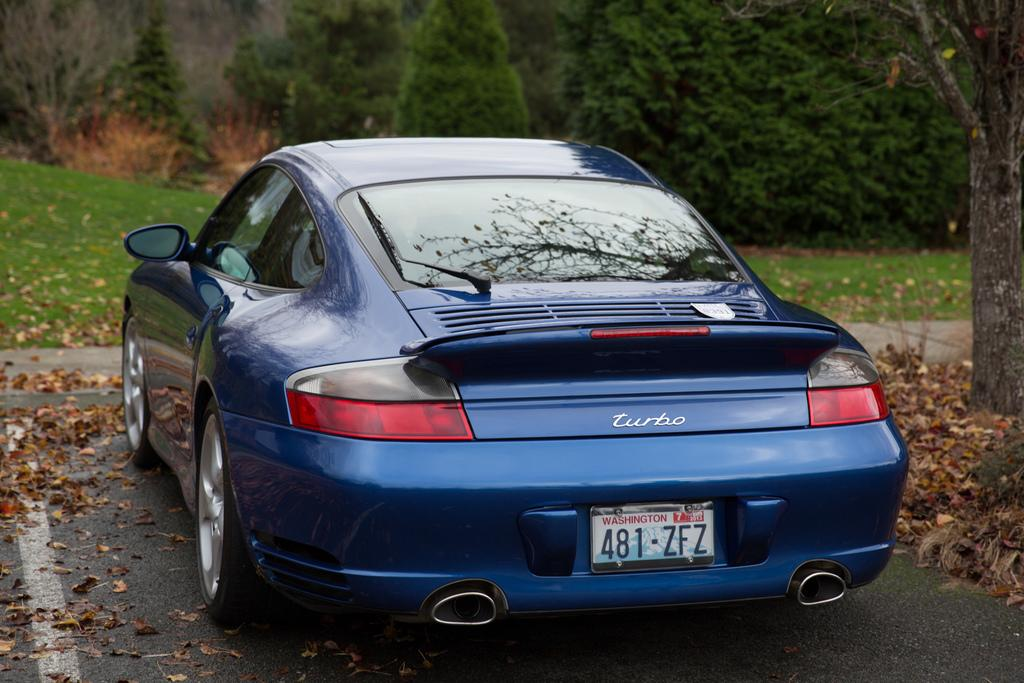<image>
Describe the image concisely. A blue car displays a plate from Washington that reads, "481-ZFZ." 